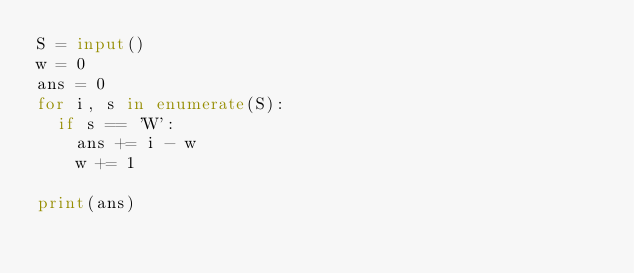Convert code to text. <code><loc_0><loc_0><loc_500><loc_500><_Python_>S = input()
w = 0
ans = 0
for i, s in enumerate(S):
  if s == 'W':
    ans += i - w
    w += 1
    
print(ans)</code> 